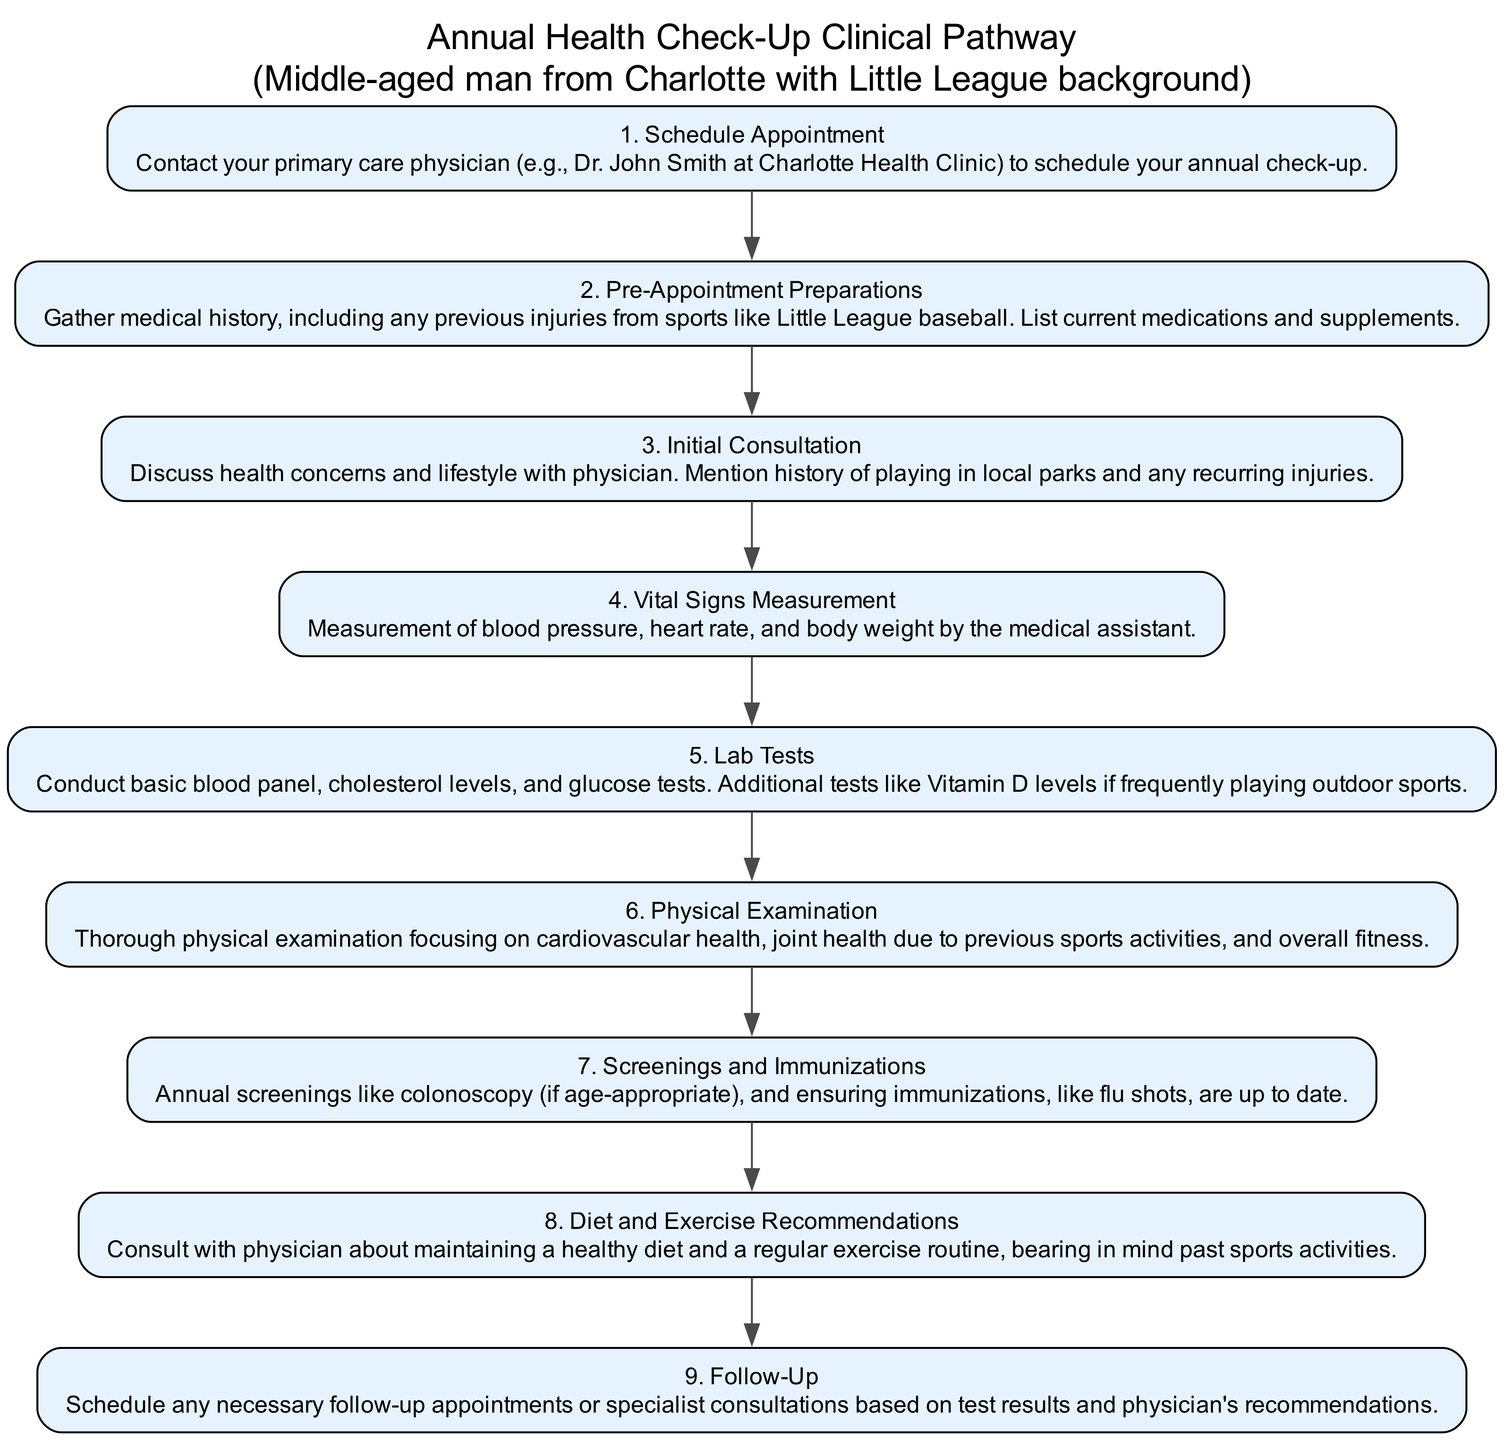What's the total number of steps in the pathway? The diagram lists 9 steps in the Annual Health Check-Up Routine, each uniquely identified by a StepID. By counting these steps from StepID 1 to StepID 9, we confirm that there are 9 steps in total.
Answer: 9 What does Step 4 measure? In Step 4, the process involves the measurement of vital signs which specifically includes blood pressure, heart rate, and body weight. These measurements are standard procedures during a health check-up to assess overall health.
Answer: Vital signs What is required during the Pre-Appointment Preparations? During Pre-Appointment Preparations (Step 2), it is necessary to gather medical history, including any previous injuries, and to compile a list of current medications and supplements. This preparation ensures that the physician has a complete view of the patient's health.
Answer: Medical history, medications, supplements Which step discusses lifestyle choices? Step 8 focuses on Diet and Exercise Recommendations, where the physician consults with the patient about maintaining a healthy diet and regular exercise routine based on their past sports activities and current health status.
Answer: Step 8 What comes directly after the Initial Consultation? The flow of the pathway indicates that after the Initial Consultation (Step 3), the next step is the measurement of Vital Signs (Step 4). This sequential order is critical as it follows the physician's initial assessment with tangible health metrics.
Answer: Step 4 What is the necessary follow-up based on? The Follow-Up (Step 9) is based on test results and the physician's recommendations after completing the entire health check-up process. This ensures that any issues detected during the appointment are addressed appropriately.
Answer: Test results and physician's recommendations What does Step 7 ensure? Step 7 ensures that annual screenings, such as colonoscopy if age-appropriate, and immunizations, including flu shots, are up to date. This step is crucial for preventative health measures according to age and risk factors.
Answer: Annual screenings and immunizations What is included in the lab tests? The lab tests conducted during Step 5 include a basic blood panel, cholesterol levels, and glucose tests. Additionally, Vitamin D levels may be tested, especially for someone engaged in outdoor sports.
Answer: Basic blood panel, cholesterol levels, glucose tests How many consultations are indicated in the pathway? The pathway indicates two main consultations: the Initial Consultation (Step 3) and the Follow-Up (Step 9). These consultations are essential for discussing health concerns initially and addressing any findings later.
Answer: Two consultations 